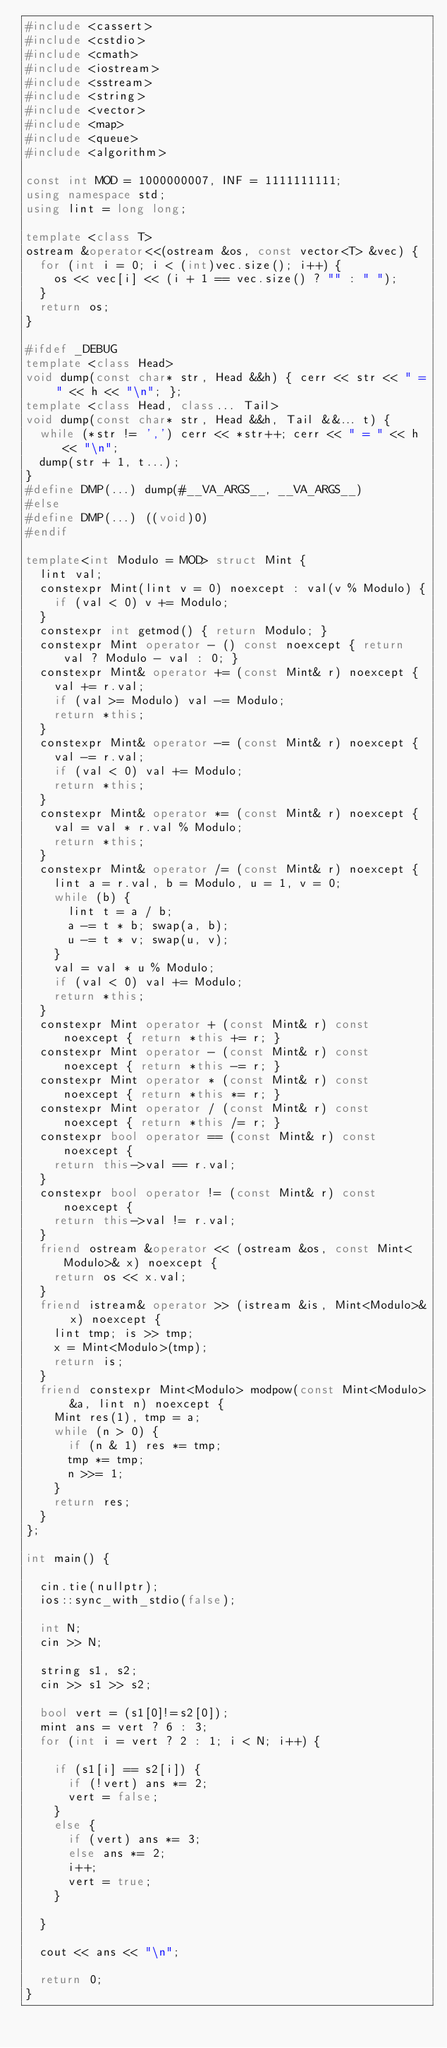<code> <loc_0><loc_0><loc_500><loc_500><_C++_>#include <cassert>
#include <cstdio>
#include <cmath>
#include <iostream>
#include <sstream>
#include <string>
#include <vector>
#include <map>
#include <queue>
#include <algorithm>

const int MOD = 1000000007, INF = 1111111111;
using namespace std;
using lint = long long;

template <class T>
ostream &operator<<(ostream &os, const vector<T> &vec) {
	for (int i = 0; i < (int)vec.size(); i++) {
		os << vec[i] << (i + 1 == vec.size() ? "" : " ");
	}
	return os;
}

#ifdef _DEBUG
template <class Head>
void dump(const char* str, Head &&h) { cerr << str << " = " << h << "\n"; };
template <class Head, class... Tail>
void dump(const char* str, Head &&h, Tail &&... t) {
	while (*str != ',') cerr << *str++; cerr << " = " << h << "\n";
	dump(str + 1, t...);
}
#define DMP(...) dump(#__VA_ARGS__, __VA_ARGS__)
#else 
#define DMP(...) ((void)0)
#endif

template<int Modulo = MOD> struct Mint {
	lint val;
	constexpr Mint(lint v = 0) noexcept : val(v % Modulo) {
		if (val < 0) v += Modulo;
	}
	constexpr int getmod() { return Modulo; }
	constexpr Mint operator - () const noexcept { return val ? Modulo - val : 0; }
	constexpr Mint& operator += (const Mint& r) noexcept {
		val += r.val;
		if (val >= Modulo) val -= Modulo;
		return *this;
	}
	constexpr Mint& operator -= (const Mint& r) noexcept {
		val -= r.val;
		if (val < 0) val += Modulo;
		return *this;
	}
	constexpr Mint& operator *= (const Mint& r) noexcept {
		val = val * r.val % Modulo;
		return *this;
	}
	constexpr Mint& operator /= (const Mint& r) noexcept {
		lint a = r.val, b = Modulo, u = 1, v = 0;
		while (b) {
			lint t = a / b;
			a -= t * b; swap(a, b);
			u -= t * v; swap(u, v);
		}
		val = val * u % Modulo;
		if (val < 0) val += Modulo;
		return *this;
	}
	constexpr Mint operator + (const Mint& r) const noexcept { return *this += r; }
	constexpr Mint operator - (const Mint& r) const noexcept { return *this -= r; }
	constexpr Mint operator * (const Mint& r) const noexcept { return *this *= r; }
	constexpr Mint operator / (const Mint& r) const noexcept { return *this /= r; }
	constexpr bool operator == (const Mint& r) const noexcept {
		return this->val == r.val;
	}
	constexpr bool operator != (const Mint& r) const noexcept {
		return this->val != r.val;
	}
	friend ostream &operator << (ostream &os, const Mint<Modulo>& x) noexcept {
		return os << x.val;
	}
	friend istream& operator >> (istream &is, Mint<Modulo>& x) noexcept {
		lint tmp; is >> tmp;
		x = Mint<Modulo>(tmp);
		return is;
	}
	friend constexpr Mint<Modulo> modpow(const Mint<Modulo> &a, lint n) noexcept {
		Mint res(1), tmp = a;
		while (n > 0) {
			if (n & 1) res *= tmp;
			tmp *= tmp;
			n >>= 1;
		}
		return res;
	}
};

int main() {

	cin.tie(nullptr);
	ios::sync_with_stdio(false);

	int N;
	cin >> N;

	string s1, s2;
	cin >> s1 >> s2;

	bool vert = (s1[0]!=s2[0]);
	mint ans = vert ? 6 : 3;
	for (int i = vert ? 2 : 1; i < N; i++) {

		if (s1[i] == s2[i]) {
			if (!vert) ans *= 2;
			vert = false;
		}
		else {
			if (vert) ans *= 3;
			else ans *= 2;
			i++;
			vert = true;
		}

	}

	cout << ans << "\n";

	return 0;
}
</code> 